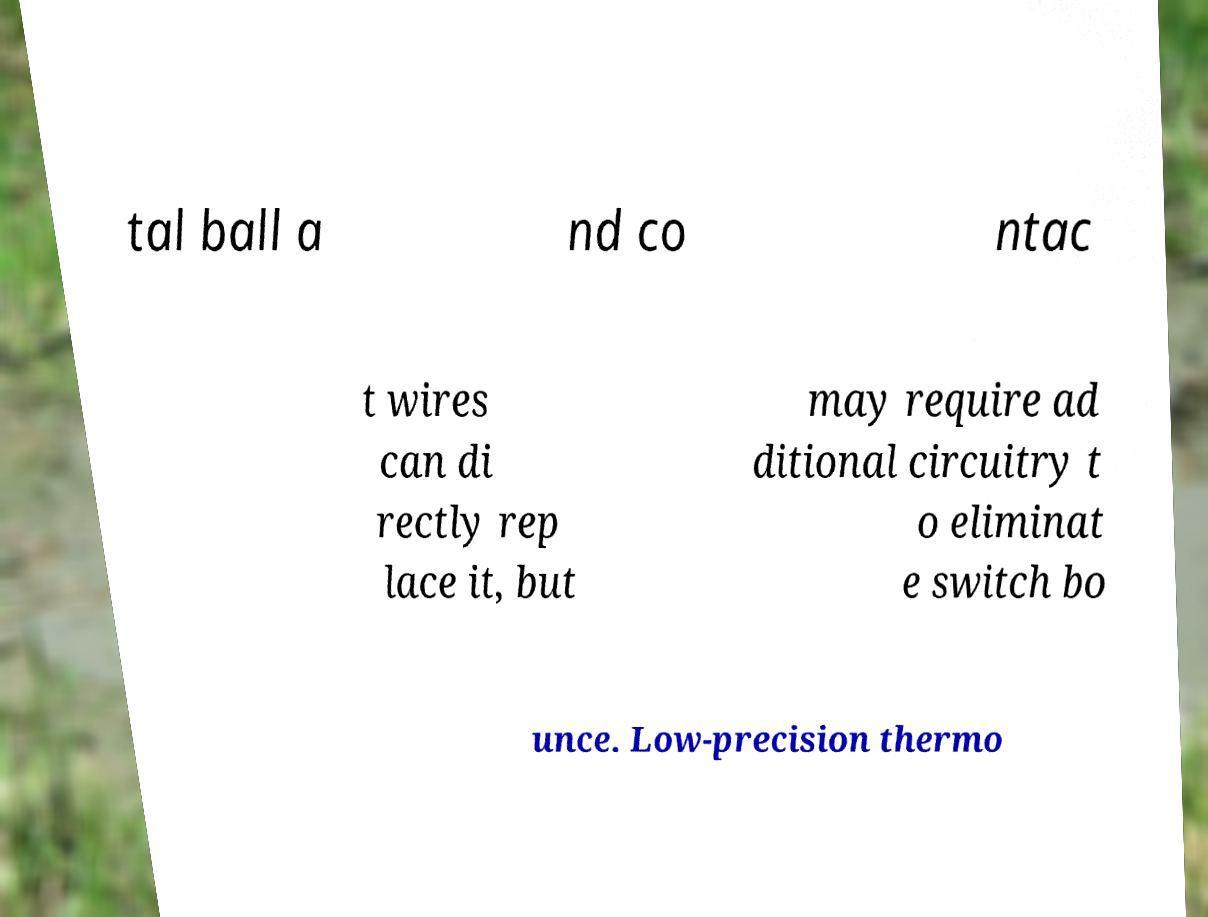Please read and relay the text visible in this image. What does it say? tal ball a nd co ntac t wires can di rectly rep lace it, but may require ad ditional circuitry t o eliminat e switch bo unce. Low-precision thermo 